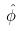<formula> <loc_0><loc_0><loc_500><loc_500>\hat { \phi }</formula> 